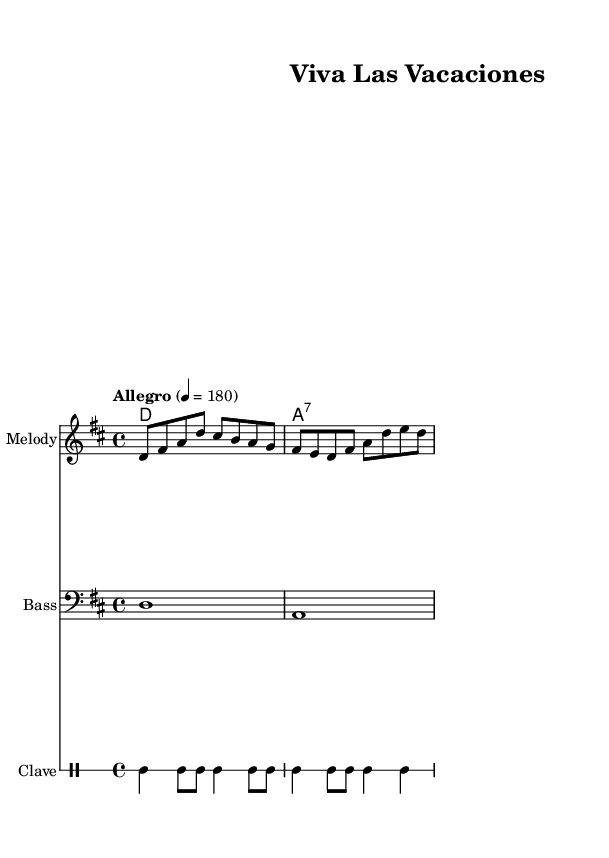What is the key signature of this music? The key signature indicates that the music is in D major, which has two sharps: F# and C#. This information can be found at the beginning of the music, where the key signature is placed.
Answer: D major What is the time signature of the piece? The time signature is 4/4, which is indicated near the beginning of the sheet music. This means there are four beats in each measure and the quarter note receives one beat.
Answer: 4/4 What is the tempo marking for this piece? The tempo marking is "Allegro" with a metronome marking of 180 beats per minute, which tells the performer to play at a fast and lively pace. This is specified in the composite header of the score.
Answer: Allegro 4 = 180 How many measures are in the melody? The melody consists of two measures, which can be counted based on the bar lines that separate them. The measures are grouped as indicated by vertical lines.
Answer: 2 What type of musical rhythm is represented by the clave part? The clave part showcases a regular rhythmic pattern that is characteristic of Latin music, specifically based on a four-beat structure, alternating between quarter notes and eighth notes. This pattern is distinctly recognizable within the drum section.
Answer: Clave What chords are used in this piece? The piece uses a D major chord and an A seventh chord, as indicated by the chord symbols beneath the staff. Each chord is shown once per measure, defining the harmonic structure of the melody.
Answer: D and A seventh 